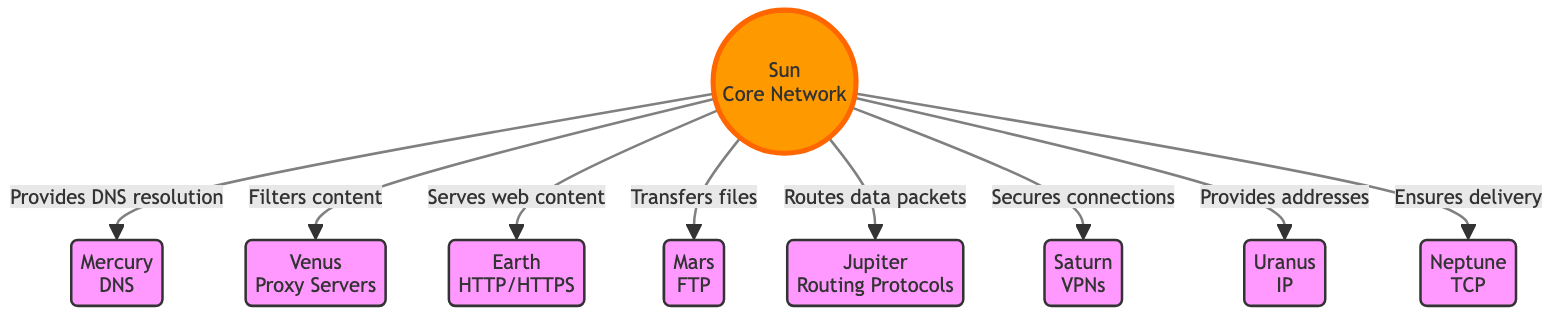What is the main role of the Sun in this diagram? The Sun is labeled as the "Core Network" and has arrows indicating that it provides various services to the planets such as DNS resolution, filtering content, serving web content, and more. Therefore, its main role is to act as a central network source that facilitates various network functions for the planets.
Answer: Core Network How many planets are depicted in this diagram? The diagram contains nine planets, which are Mercury, Venus, Earth, Mars, Jupiter, Saturn, Uranus, and Neptune. By counting each of the node labels, we determine that there are a total of nine distinct planets represented.
Answer: Nine What type of service does Mars represent in the context of the Sun? According to the diagram, Mars is labeled "FTP", which indicates that its service type is for transferring files. The flow from the Sun to Mars specifies that it transfers files, making FTP the clear designation for Mars.
Answer: FTP Which planet is associated with proxy servers? The diagram indicates that Venus is associated with proxy servers, as it explicitly states "Venus<br/>Proxy Servers". This direct relationship can be confirmed by checking the label of the Venus node.
Answer: Proxy Servers What function does Jupiter serve in this network analogy? Jupiter is labeled with "Routing Protocols" and is connected to the Sun with an arrow indicating it "Routes data packets". This suggests that Jupiter's function in this analogy mirrors that of routing protocols in computer networks, which are responsible for directing data packets through the network.
Answer: Routing Protocols Which planet ensures delivery, and what protocol does it correspond to? Neptune is the planet labeled with "TCP", and according to the flow, it "Ensures delivery". This means that Neptune is associated with the Transmission Control Protocol, which is a core element in ensuring the reliable delivery of data packets in a network.
Answer: TCP What does Saturn signify in the diagram? The diagram shows Saturn labeled as "VPNs", and the arrow connecting it to the Sun indicates that it "Secures connections". This signifies that Saturn's role in the network context is related to virtual private networks that provide secured connections over the internet.
Answer: VPNs Which planet provides DNS resolution? Mercury is designated with the label "DNS", and there is a direct connection from the Sun stating that it "Provides DNS resolution". This clarifies that Mercury functions as the DNS server in this network analogy.
Answer: DNS Describe the relationship between the Earth and the Sun as depicted in the diagram. The diagram shows that Earth is labeled with "HTTP/HTTPS" and has a direct flow from the Sun labeled "Serves web content". This indicates that the Sun serves as a source of web content delivery for Earth, emphasizing the relationship between the Sun and Earth in the context of web protocols.
Answer: Serves web content What entity is indicated as the main source for all planetary connections? The Sun is represented as the core element at the center of the diagram, with all planetary nodes connected to it by arrows showing various flows of communication, indicating that it serves as the main source for all planetary connections in this analogy.
Answer: Sun 